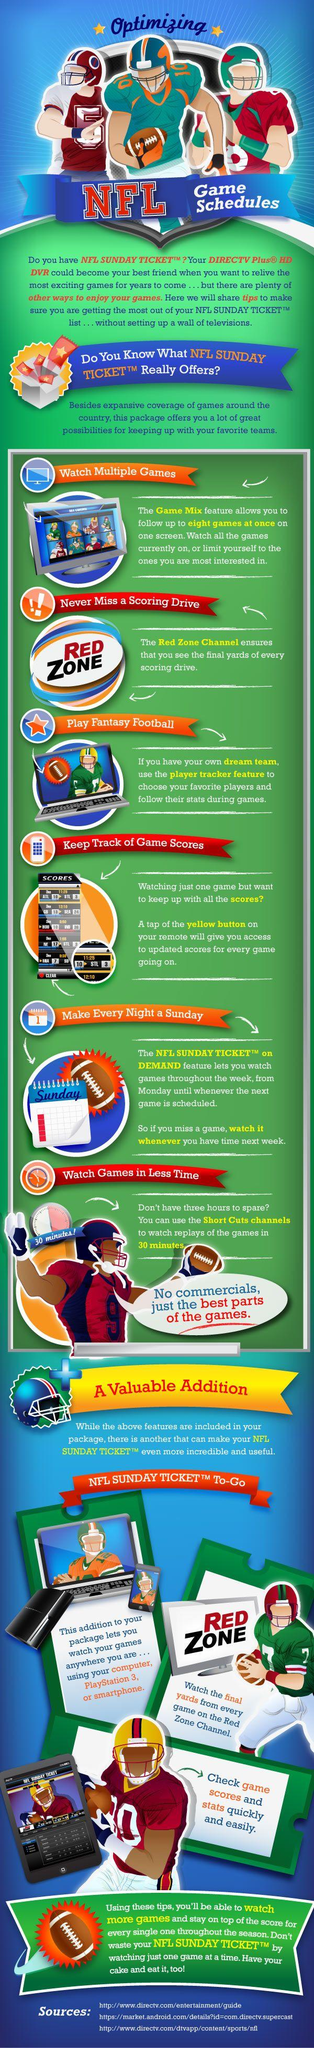Outline some significant characteristics in this image. NFL Sunday Ticket To-Go offers the feature that enables users to watch games on their smartphones, computers, or PlayStation 3. 